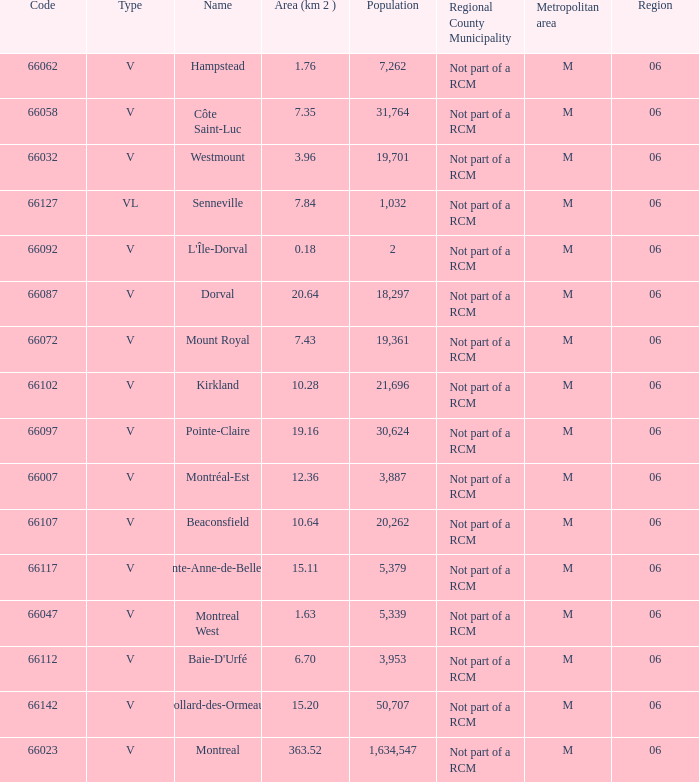What is the largest area with a Code of 66097, and a Region larger than 6? None. 